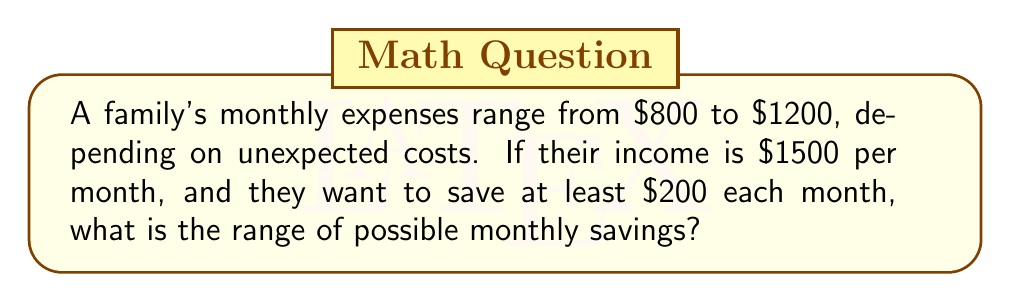Give your solution to this math problem. Let's approach this step-by-step:

1) First, we need to set up an inequality to represent the savings:
   $$ \text{Savings} = \text{Income} - \text{Expenses} $$

2) We know that:
   - Income is fixed at $1500
   - Expenses range from $800 to $1200
   - They want to save at least $200

3) Let's represent the minimum savings scenario:
   $$ \text{Min Savings} = 1500 - 1200 = 300 $$

4) Now, let's represent the maximum savings scenario:
   $$ \text{Max Savings} = 1500 - 800 = 700 $$

5) Therefore, the range of possible savings is $300 to $700.

6) We can represent this as an inequality:
   $$ 300 \leq \text{Savings} \leq 700 $$

7) Since they want to save at least $200, this condition is already satisfied by the minimum savings of $300.
Answer: $[300, 700]$ 